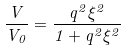Convert formula to latex. <formula><loc_0><loc_0><loc_500><loc_500>\frac { V } { V _ { 0 } } = \frac { q ^ { 2 } \xi ^ { 2 } } { 1 + q ^ { 2 } \xi ^ { 2 } }</formula> 